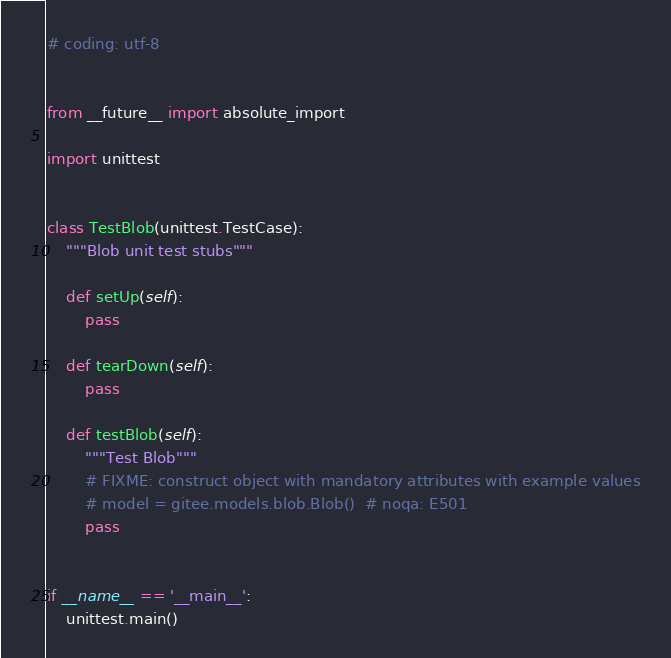Convert code to text. <code><loc_0><loc_0><loc_500><loc_500><_Python_># coding: utf-8


from __future__ import absolute_import

import unittest


class TestBlob(unittest.TestCase):
    """Blob unit test stubs"""

    def setUp(self):
        pass

    def tearDown(self):
        pass

    def testBlob(self):
        """Test Blob"""
        # FIXME: construct object with mandatory attributes with example values
        # model = gitee.models.blob.Blob()  # noqa: E501
        pass


if __name__ == '__main__':
    unittest.main()
</code> 